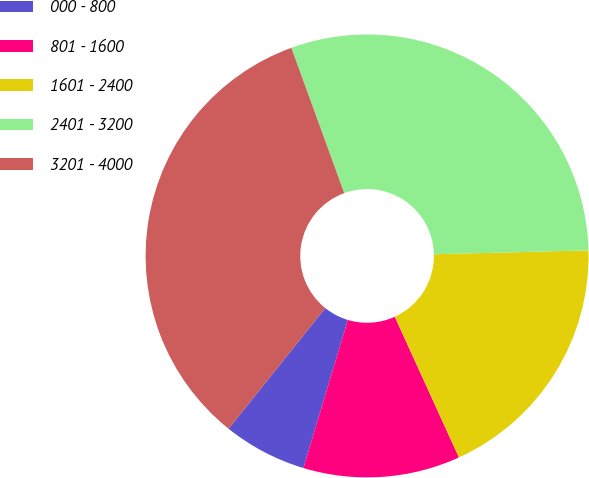Convert chart. <chart><loc_0><loc_0><loc_500><loc_500><pie_chart><fcel>000 - 800<fcel>801 - 1600<fcel>1601 - 2400<fcel>2401 - 3200<fcel>3201 - 4000<nl><fcel>6.11%<fcel>11.45%<fcel>18.59%<fcel>30.16%<fcel>33.69%<nl></chart> 